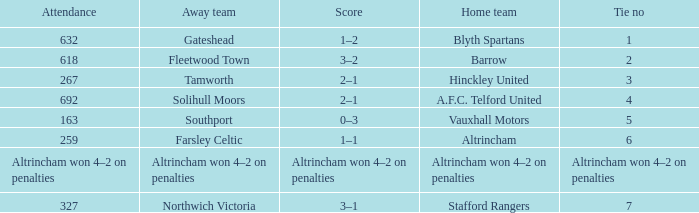During the 7 ties, what was the overall score? 3–1. 